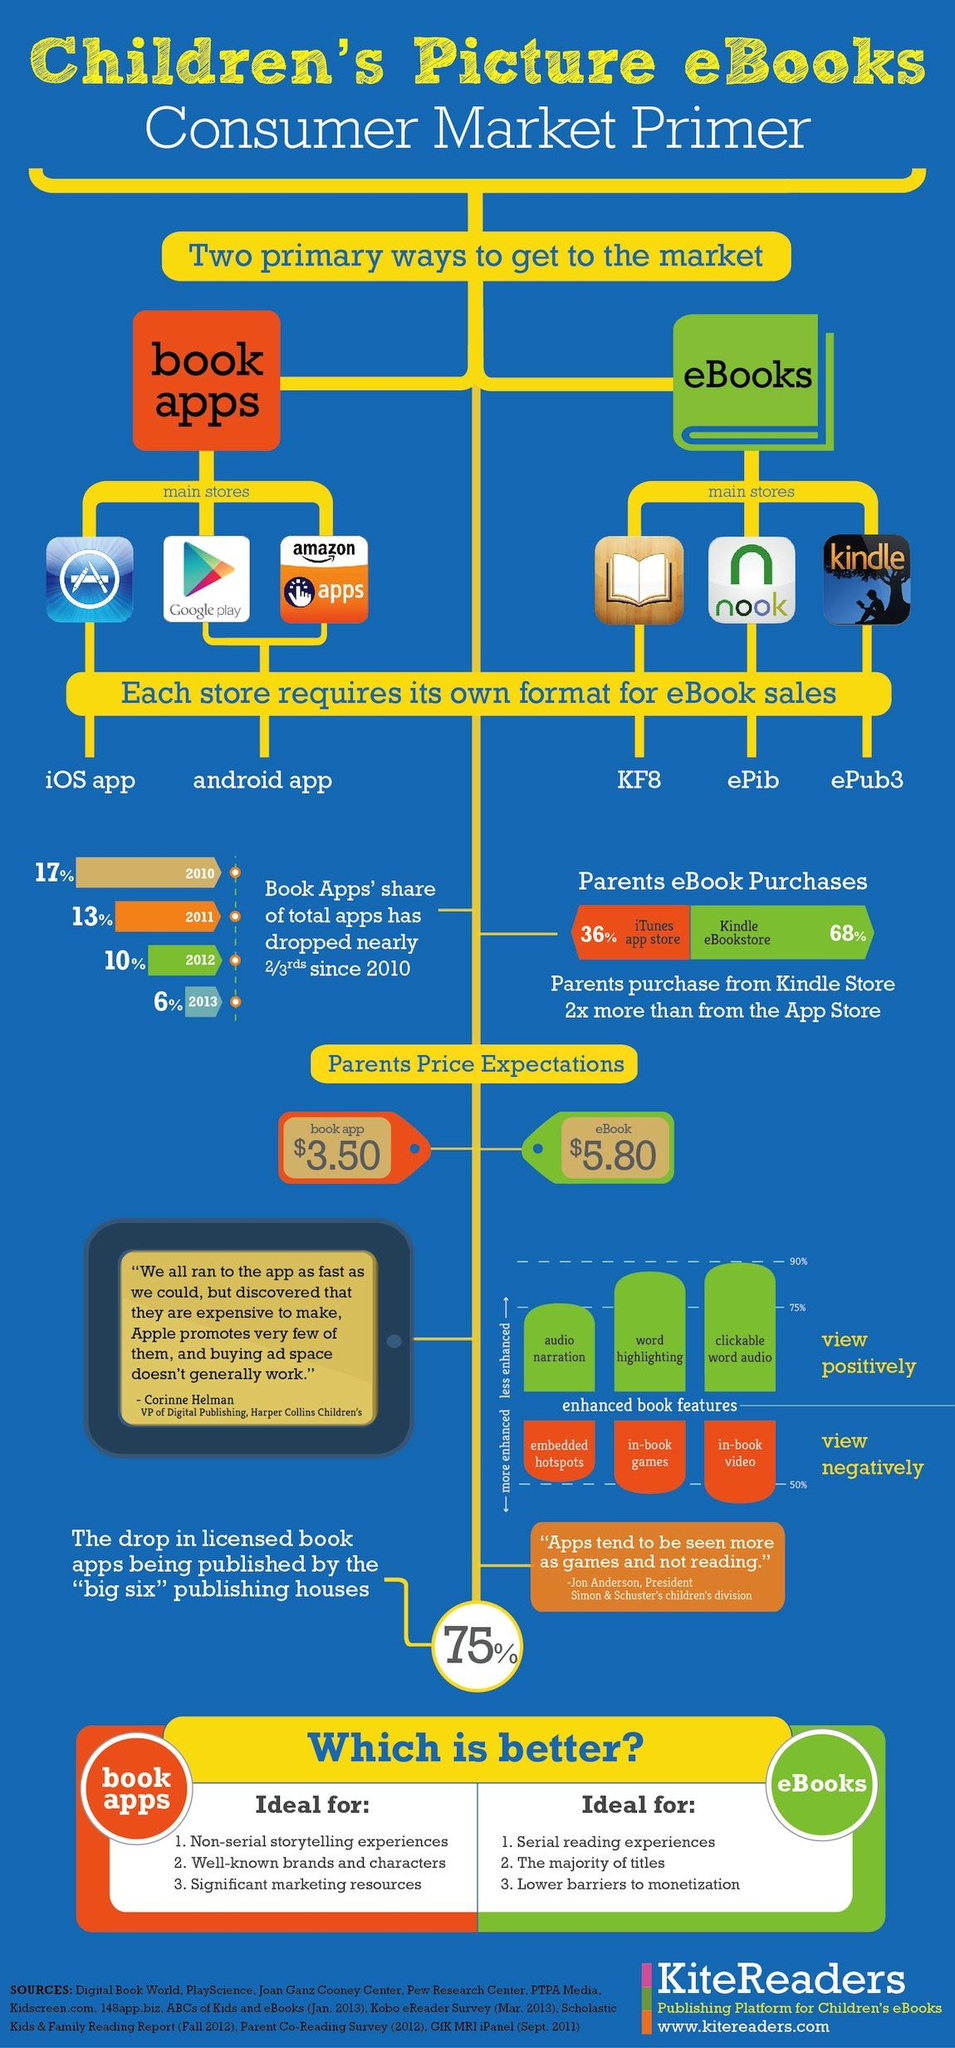Identify some key points in this picture. The format of the Nook store is ePub. The Kindle store uses the ePub3 format. The parent has a price expectation of 9.3 for the book app and eBook when taken together. 